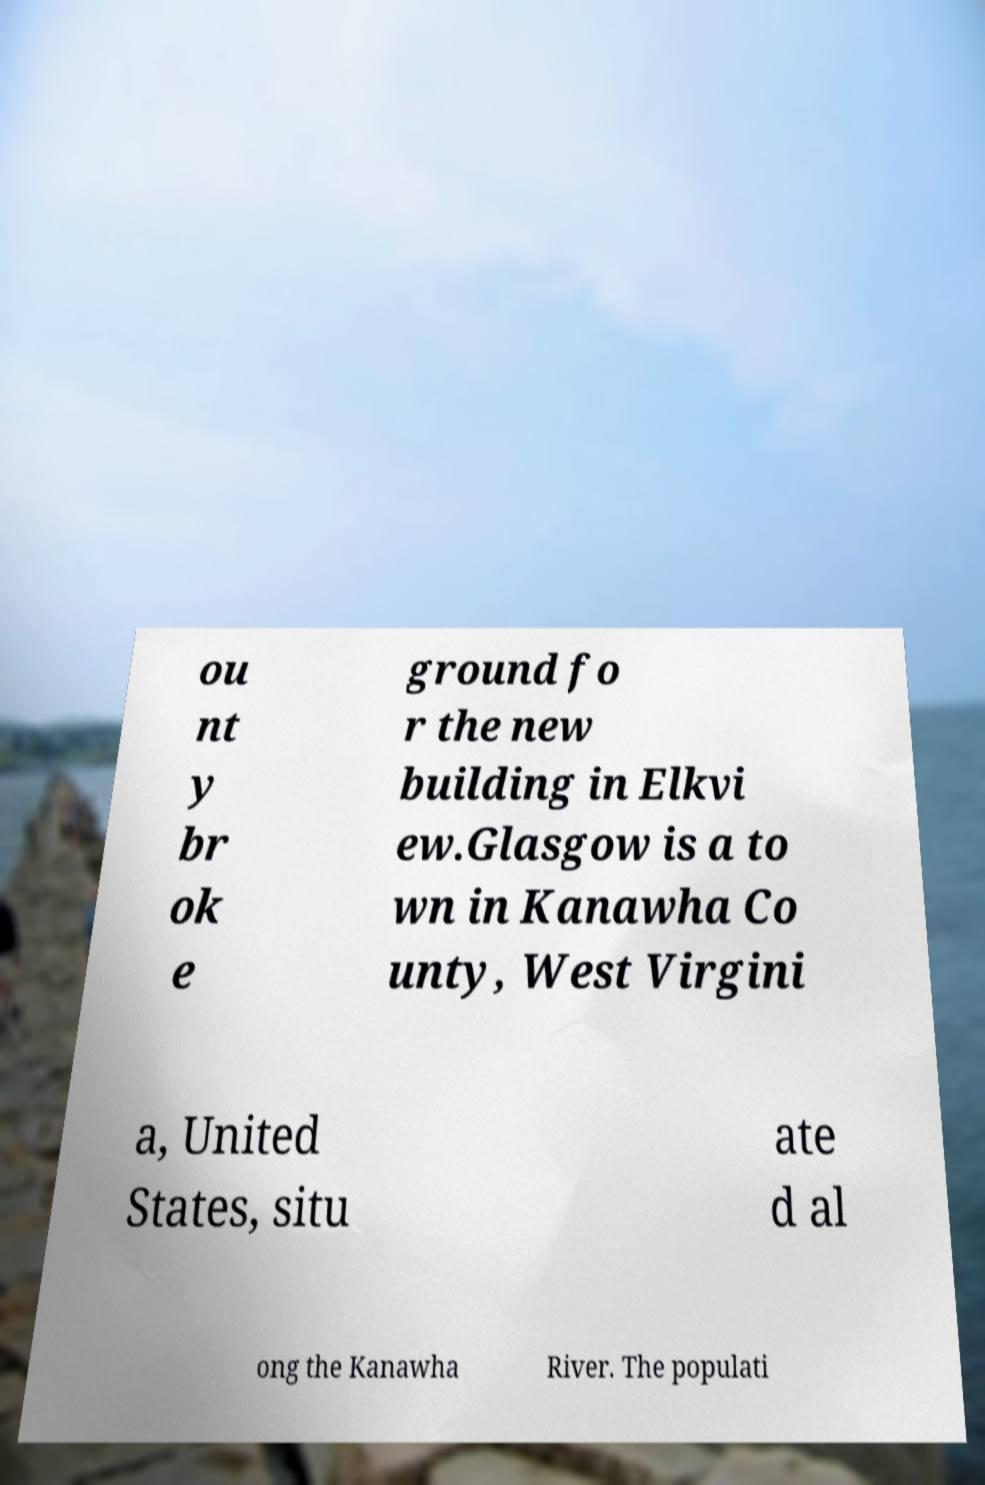What messages or text are displayed in this image? I need them in a readable, typed format. ou nt y br ok e ground fo r the new building in Elkvi ew.Glasgow is a to wn in Kanawha Co unty, West Virgini a, United States, situ ate d al ong the Kanawha River. The populati 